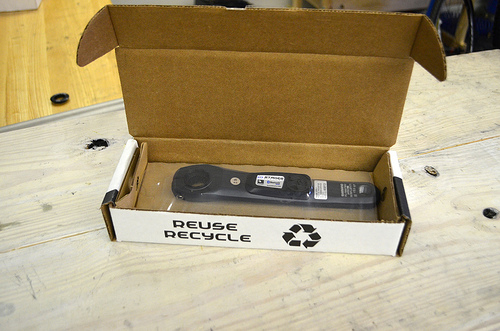<image>
Is there a box on the table? Yes. Looking at the image, I can see the box is positioned on top of the table, with the table providing support. 